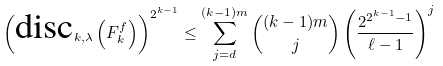<formula> <loc_0><loc_0><loc_500><loc_500>\left ( \text {disc} _ { k , \lambda } \left ( F ^ { f } _ { k } \right ) \right ) ^ { 2 ^ { k - 1 } } \leq \sum _ { j = d } ^ { ( k - 1 ) m } { ( k - 1 ) m \choose j } \left ( \frac { 2 ^ { 2 ^ { k - 1 } - 1 } } { \ell - 1 } \right ) ^ { j }</formula> 